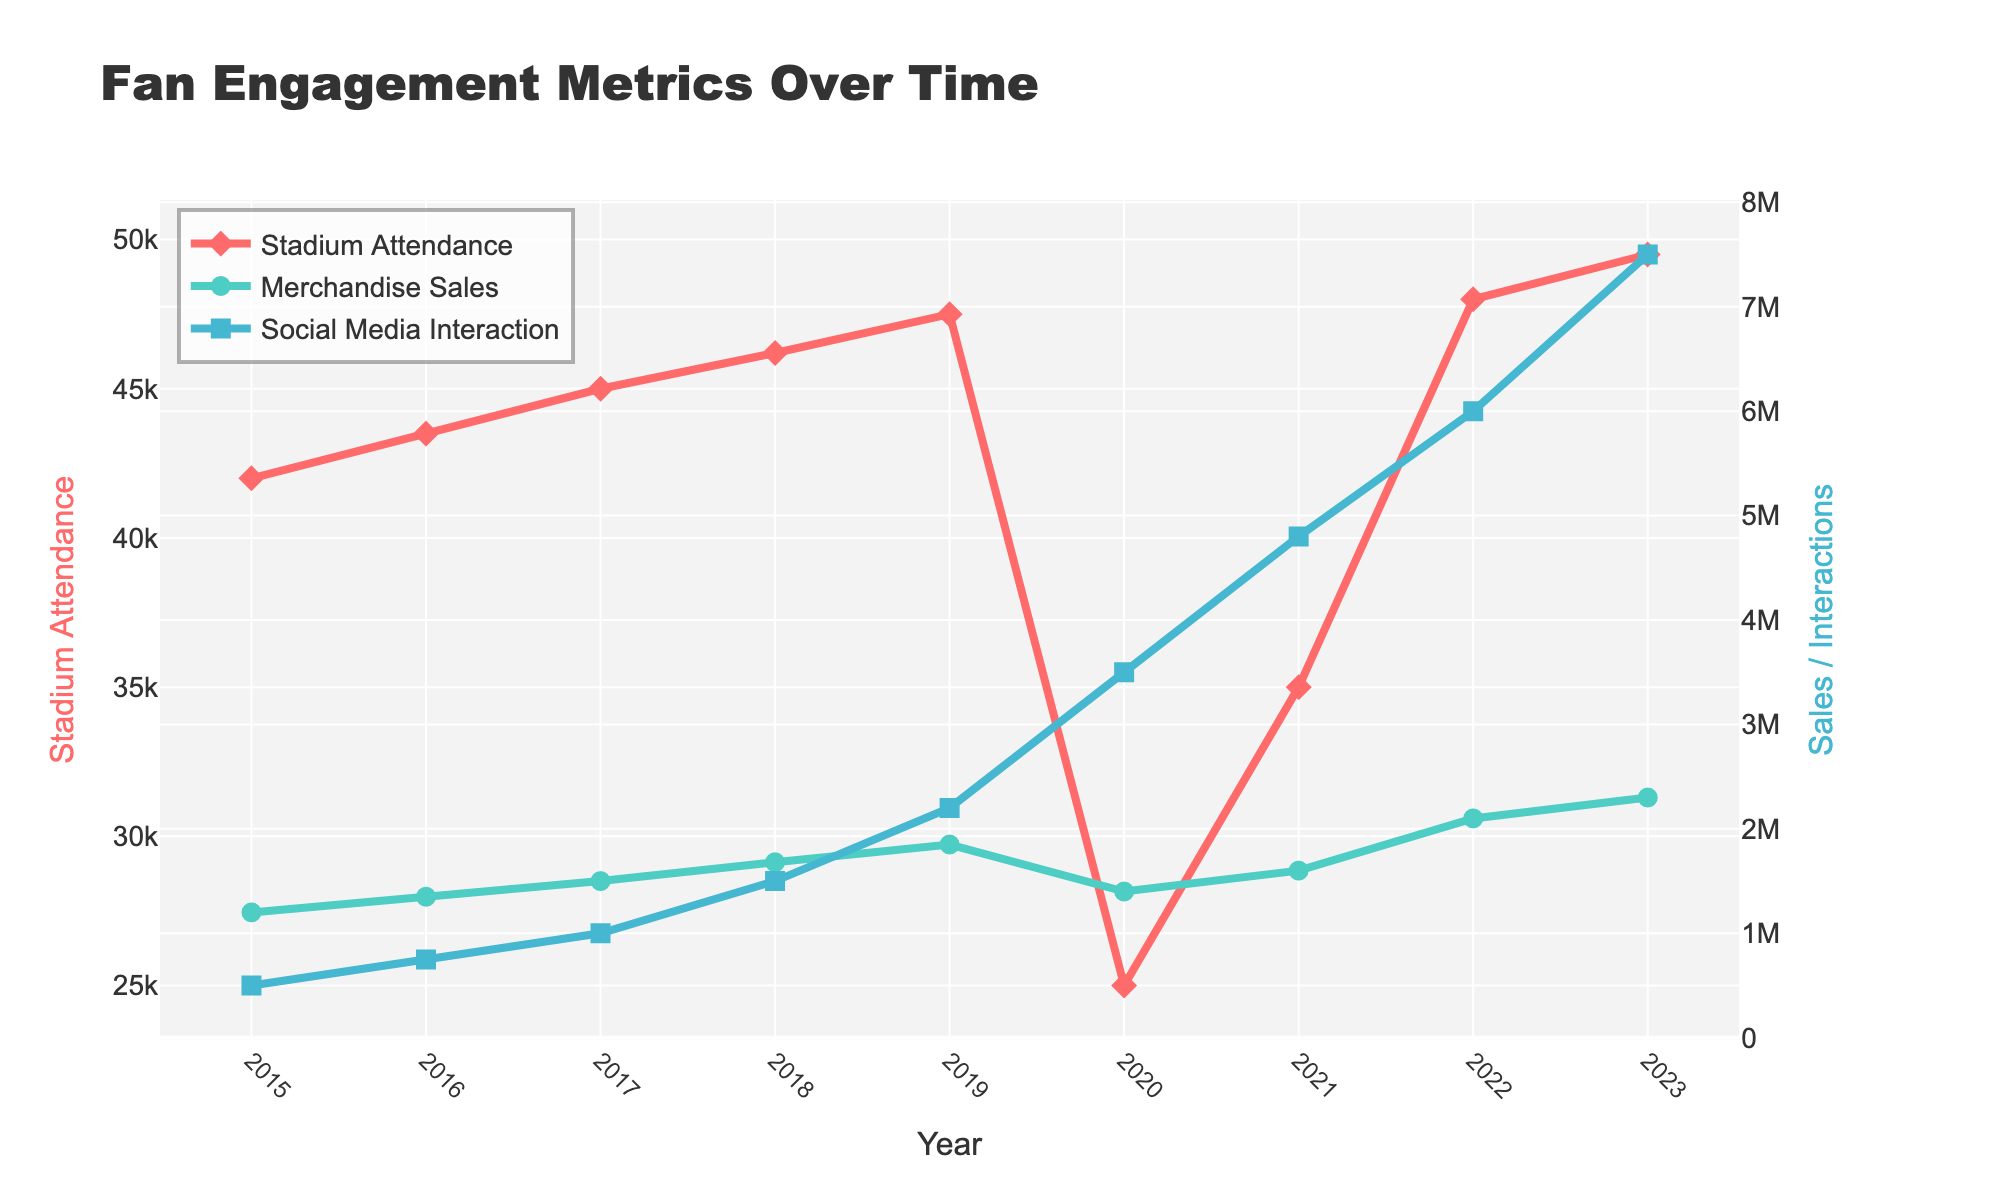What was the Stadium Attendance in 2020? From the figure, locate the data point for the year 2020 on the red line representing Stadium Attendance and read the value.
Answer: 25000 In which year did Merchandise Sales surpass 2 million? Observe the green line representing Merchandise Sales and find the year when it first crosses the 2 million mark.
Answer: 2022 Compare Social Media Interaction between 2017 and 2019. Which year had higher interaction? Locate the data points for 2017 and 2019 on the blue line representing Social Media Interaction and compare the values.
Answer: 2019 What is the average Stadium Attendance from 2015 to 2019? Sum the Stadium Attendance values from 2015 to 2019 and divide by the number of years (5). (42000 + 43500 + 45000 + 46200 + 47500) / 5 = 44840
Answer: 44840 How did the Social Media Interaction change from 2019 to 2020? Compare the values for Social Media Interaction in 2019 and 2020. Calculate the difference to understand the change. 3500000 - 2200000 = 1300000. Social Media Interaction increased by this amount.
Answer: Increased by 1300000 Which metric showed the most dramatic change in 2020? Compare the changes in Stadium Attendance, Merchandise Sales, and Social Media Interaction between 2019 and 2020. Identify the metric with the largest change. Stadium Attendance dropped significantly, Merchandise Sales also dropped but to a lesser degree, while Social Media Interaction increased dramatically.
Answer: Social Media Interaction What was the total Merchandise Sales over the years 2021 and 2022 combined? Sum the Merchandise Sales values for 2021 and 2022. 1600000 + 2100000 = 3700000
Answer: 3700000 In which year was the gap between Stadium Attendance and Social Media Interaction the widest? Calculate the difference between Stadium Attendance and Social Media Interaction for each year and identify the year with the largest gap. The widest gap is in 2023. 7500000 - 49500 ≈ 7450500
Answer: 2023 How did Merchandise Sales change from 2018 to 2019? Did it increase or decrease? By how much? Compare the values for Merchandise Sales in 2018 and 2019. Merchandise Sales increased; 1850000 - 1680000 = 170000
Answer: Increased by 170000 